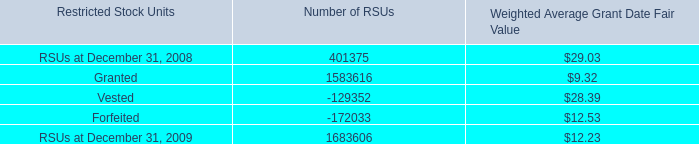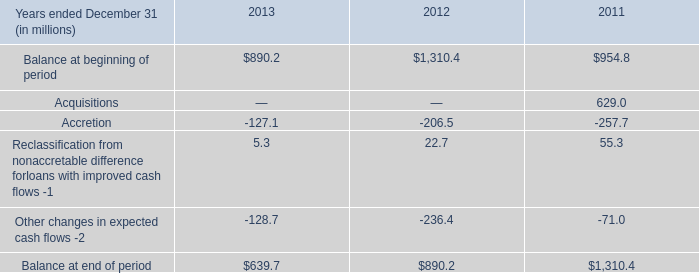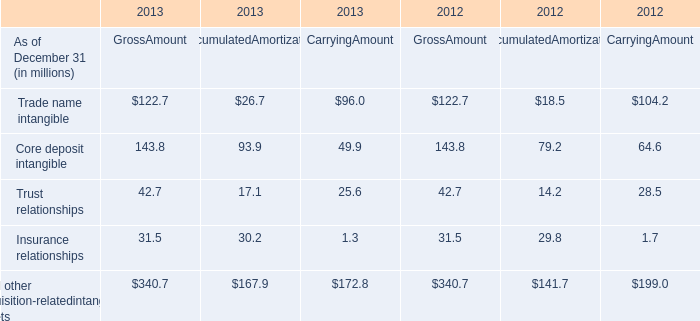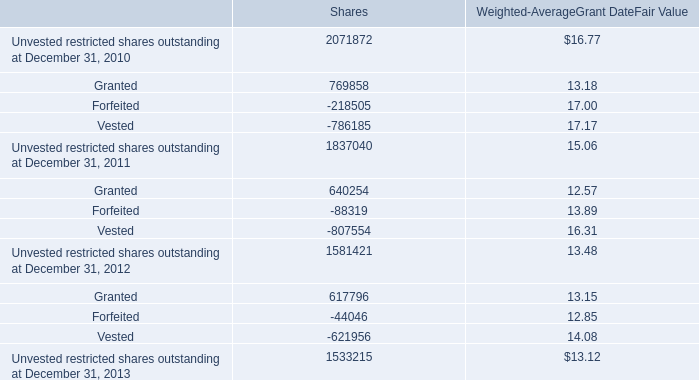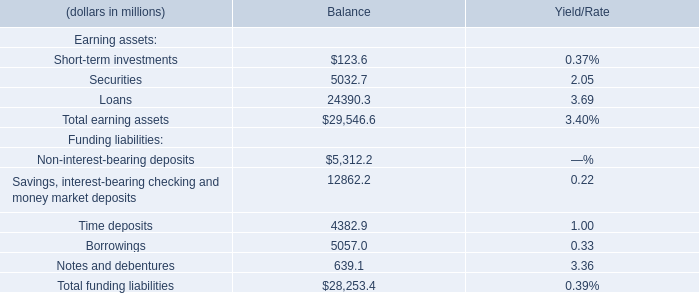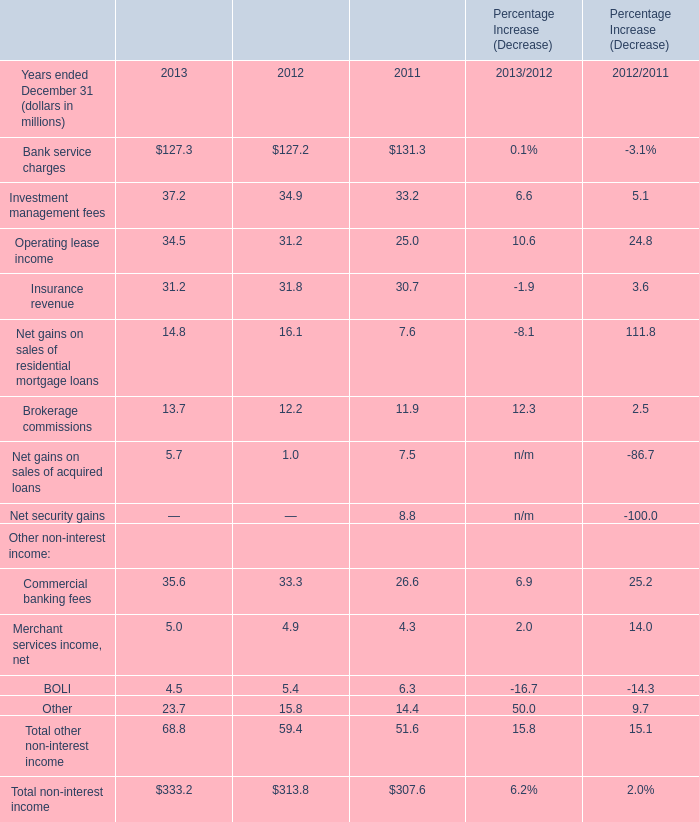What's the sum of RSUs at December 31, 2008 of Number of RSUs, and Unvested restricted shares outstanding at December 31, 2013 of Shares ? 
Computations: (401375.0 + 1533215.0)
Answer: 1934590.0. 